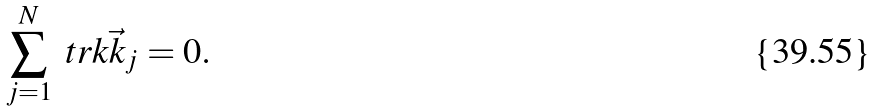<formula> <loc_0><loc_0><loc_500><loc_500>\sum _ { j = 1 } ^ { N } \ t r k { \vec { k } _ { j } } = 0 .</formula> 